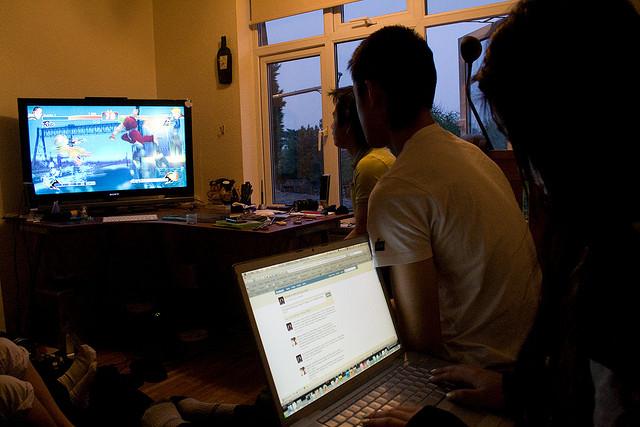What is the man doing?
Keep it brief. Sitting. What game is this person playing?
Quick response, please. Street fighter. Is this a classroom?
Keep it brief. No. What game system is the man playing?
Give a very brief answer. Xbox. Is the girl on a laptop?
Short answer required. Yes. What type of computers are pictured?
Give a very brief answer. Laptop. Do you see a sewing machine?
Quick response, please. No. How many computer screens?
Write a very short answer. 1. Are these people friends?
Quick response, please. Yes. What is hanging up in the windows?
Short answer required. Blinds. What game platform is the man using?
Answer briefly. Wii. What color shirt is the man wearing?
Quick response, please. White. What time is it?
Short answer required. Evening. Was this taken at night?
Write a very short answer. No. 